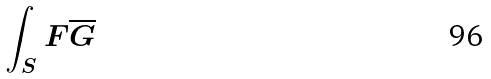Convert formula to latex. <formula><loc_0><loc_0><loc_500><loc_500>\int _ { S } F \overline { G }</formula> 